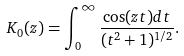Convert formula to latex. <formula><loc_0><loc_0><loc_500><loc_500>K _ { 0 } ( z ) = \int _ { 0 } ^ { \infty } \frac { \cos ( z t ) d t } { ( t ^ { 2 } + 1 ) ^ { 1 / 2 } } .</formula> 